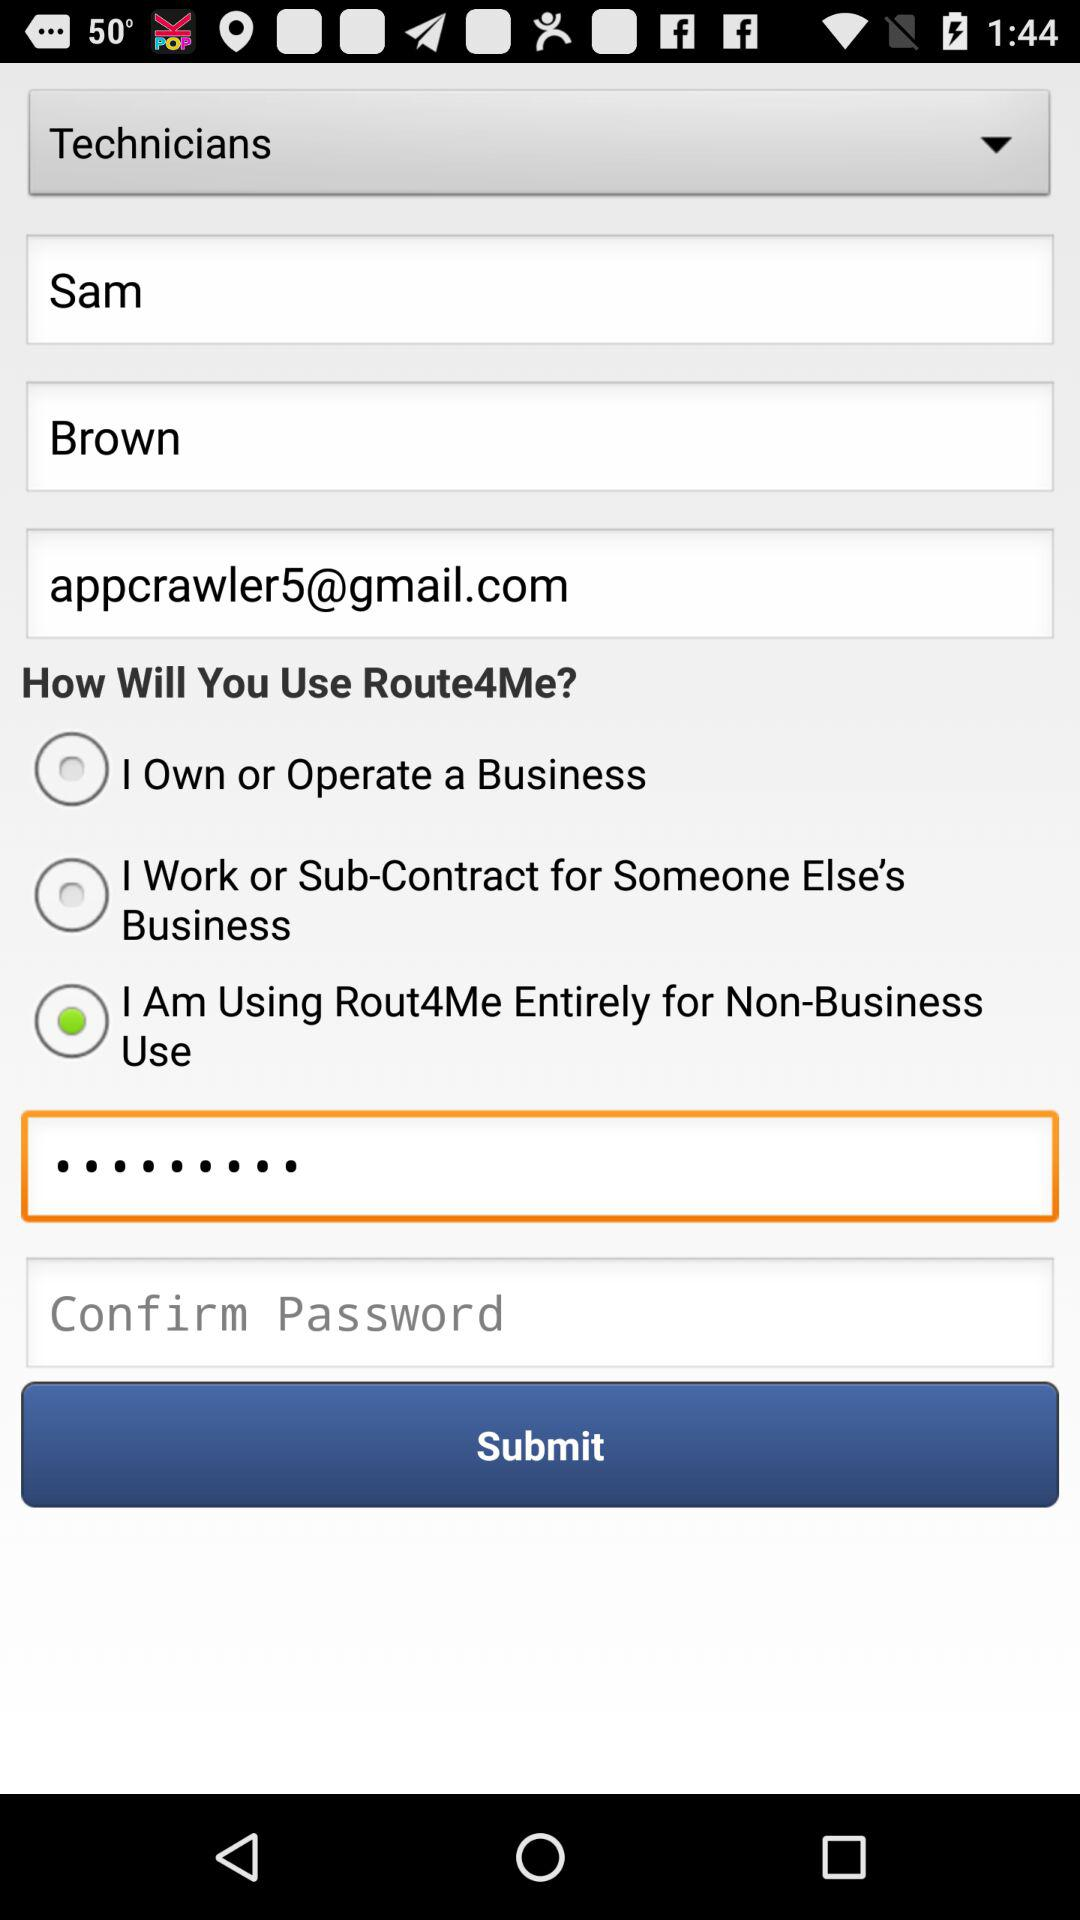In order to use Route4Me, what option is selected? The selected option is "I Am Using Rout4Me Entirely for Non-Business Use". 